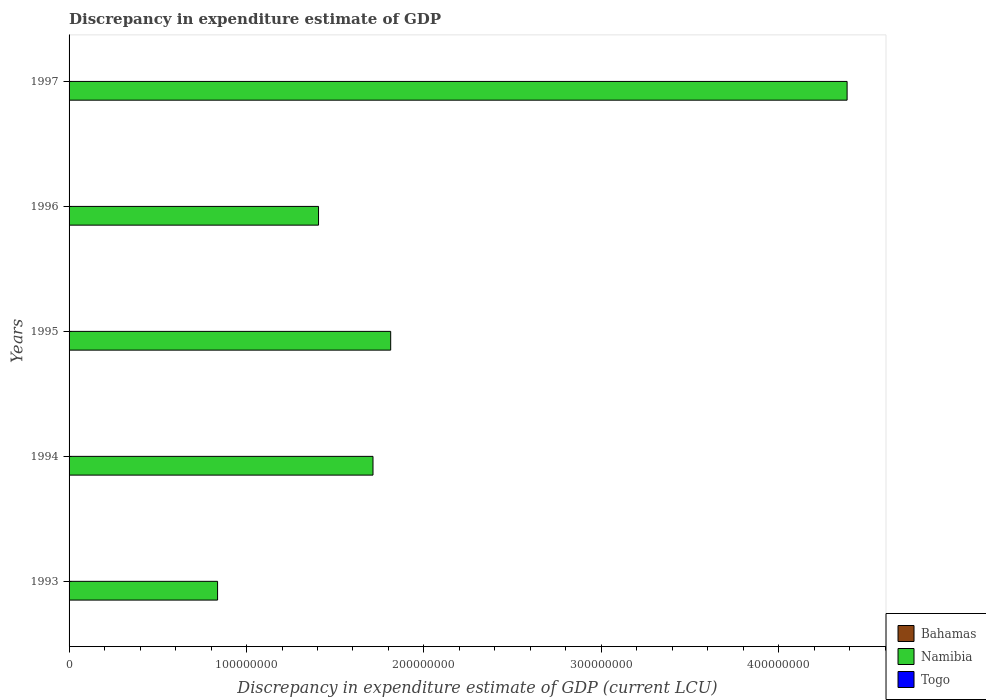How many different coloured bars are there?
Make the answer very short. 2. What is the label of the 3rd group of bars from the top?
Ensure brevity in your answer.  1995. What is the discrepancy in expenditure estimate of GDP in Togo in 1993?
Your answer should be compact. 1.02e+04. Across all years, what is the maximum discrepancy in expenditure estimate of GDP in Namibia?
Your answer should be compact. 4.38e+08. What is the total discrepancy in expenditure estimate of GDP in Togo in the graph?
Keep it short and to the point. 5.12e+04. What is the difference between the discrepancy in expenditure estimate of GDP in Namibia in 1994 and that in 1996?
Provide a short and direct response. 3.07e+07. What is the difference between the discrepancy in expenditure estimate of GDP in Togo in 1993 and the discrepancy in expenditure estimate of GDP in Bahamas in 1997?
Provide a succinct answer. 1.02e+04. In the year 1997, what is the difference between the discrepancy in expenditure estimate of GDP in Namibia and discrepancy in expenditure estimate of GDP in Togo?
Offer a very short reply. 4.38e+08. In how many years, is the discrepancy in expenditure estimate of GDP in Togo greater than 60000000 LCU?
Keep it short and to the point. 0. What is the ratio of the discrepancy in expenditure estimate of GDP in Togo in 1993 to that in 1994?
Make the answer very short. 102. What is the difference between the highest and the second highest discrepancy in expenditure estimate of GDP in Togo?
Keep it short and to the point. 1.44e+04. What is the difference between the highest and the lowest discrepancy in expenditure estimate of GDP in Togo?
Your response must be concise. 2.45e+04. Is the sum of the discrepancy in expenditure estimate of GDP in Togo in 1995 and 1996 greater than the maximum discrepancy in expenditure estimate of GDP in Bahamas across all years?
Provide a succinct answer. Yes. How many bars are there?
Give a very brief answer. 10. Does the graph contain any zero values?
Your answer should be compact. Yes. Where does the legend appear in the graph?
Make the answer very short. Bottom right. How many legend labels are there?
Give a very brief answer. 3. What is the title of the graph?
Your answer should be very brief. Discrepancy in expenditure estimate of GDP. What is the label or title of the X-axis?
Ensure brevity in your answer.  Discrepancy in expenditure estimate of GDP (current LCU). What is the Discrepancy in expenditure estimate of GDP (current LCU) in Namibia in 1993?
Offer a very short reply. 8.37e+07. What is the Discrepancy in expenditure estimate of GDP (current LCU) of Togo in 1993?
Ensure brevity in your answer.  1.02e+04. What is the Discrepancy in expenditure estimate of GDP (current LCU) in Namibia in 1994?
Make the answer very short. 1.71e+08. What is the Discrepancy in expenditure estimate of GDP (current LCU) of Bahamas in 1995?
Your answer should be compact. 0. What is the Discrepancy in expenditure estimate of GDP (current LCU) in Namibia in 1995?
Give a very brief answer. 1.81e+08. What is the Discrepancy in expenditure estimate of GDP (current LCU) in Togo in 1995?
Offer a very short reply. 8100. What is the Discrepancy in expenditure estimate of GDP (current LCU) in Bahamas in 1996?
Offer a terse response. 0. What is the Discrepancy in expenditure estimate of GDP (current LCU) in Namibia in 1996?
Ensure brevity in your answer.  1.41e+08. What is the Discrepancy in expenditure estimate of GDP (current LCU) in Togo in 1996?
Your response must be concise. 2.46e+04. What is the Discrepancy in expenditure estimate of GDP (current LCU) in Namibia in 1997?
Keep it short and to the point. 4.38e+08. What is the Discrepancy in expenditure estimate of GDP (current LCU) in Togo in 1997?
Provide a short and direct response. 8200. Across all years, what is the maximum Discrepancy in expenditure estimate of GDP (current LCU) in Namibia?
Offer a very short reply. 4.38e+08. Across all years, what is the maximum Discrepancy in expenditure estimate of GDP (current LCU) in Togo?
Make the answer very short. 2.46e+04. Across all years, what is the minimum Discrepancy in expenditure estimate of GDP (current LCU) in Namibia?
Give a very brief answer. 8.37e+07. What is the total Discrepancy in expenditure estimate of GDP (current LCU) in Bahamas in the graph?
Provide a succinct answer. 0. What is the total Discrepancy in expenditure estimate of GDP (current LCU) in Namibia in the graph?
Make the answer very short. 1.02e+09. What is the total Discrepancy in expenditure estimate of GDP (current LCU) of Togo in the graph?
Offer a very short reply. 5.12e+04. What is the difference between the Discrepancy in expenditure estimate of GDP (current LCU) of Namibia in 1993 and that in 1994?
Offer a very short reply. -8.76e+07. What is the difference between the Discrepancy in expenditure estimate of GDP (current LCU) in Togo in 1993 and that in 1994?
Make the answer very short. 1.01e+04. What is the difference between the Discrepancy in expenditure estimate of GDP (current LCU) of Namibia in 1993 and that in 1995?
Keep it short and to the point. -9.76e+07. What is the difference between the Discrepancy in expenditure estimate of GDP (current LCU) in Togo in 1993 and that in 1995?
Your response must be concise. 2100. What is the difference between the Discrepancy in expenditure estimate of GDP (current LCU) in Namibia in 1993 and that in 1996?
Give a very brief answer. -5.69e+07. What is the difference between the Discrepancy in expenditure estimate of GDP (current LCU) of Togo in 1993 and that in 1996?
Ensure brevity in your answer.  -1.44e+04. What is the difference between the Discrepancy in expenditure estimate of GDP (current LCU) in Namibia in 1993 and that in 1997?
Make the answer very short. -3.55e+08. What is the difference between the Discrepancy in expenditure estimate of GDP (current LCU) of Togo in 1993 and that in 1997?
Provide a short and direct response. 2000. What is the difference between the Discrepancy in expenditure estimate of GDP (current LCU) of Namibia in 1994 and that in 1995?
Give a very brief answer. -9.97e+06. What is the difference between the Discrepancy in expenditure estimate of GDP (current LCU) in Togo in 1994 and that in 1995?
Provide a short and direct response. -8000. What is the difference between the Discrepancy in expenditure estimate of GDP (current LCU) in Namibia in 1994 and that in 1996?
Your answer should be compact. 3.07e+07. What is the difference between the Discrepancy in expenditure estimate of GDP (current LCU) in Togo in 1994 and that in 1996?
Provide a succinct answer. -2.45e+04. What is the difference between the Discrepancy in expenditure estimate of GDP (current LCU) of Namibia in 1994 and that in 1997?
Your answer should be compact. -2.67e+08. What is the difference between the Discrepancy in expenditure estimate of GDP (current LCU) in Togo in 1994 and that in 1997?
Keep it short and to the point. -8100. What is the difference between the Discrepancy in expenditure estimate of GDP (current LCU) in Namibia in 1995 and that in 1996?
Give a very brief answer. 4.07e+07. What is the difference between the Discrepancy in expenditure estimate of GDP (current LCU) of Togo in 1995 and that in 1996?
Offer a terse response. -1.65e+04. What is the difference between the Discrepancy in expenditure estimate of GDP (current LCU) in Namibia in 1995 and that in 1997?
Offer a very short reply. -2.57e+08. What is the difference between the Discrepancy in expenditure estimate of GDP (current LCU) in Togo in 1995 and that in 1997?
Your answer should be very brief. -100. What is the difference between the Discrepancy in expenditure estimate of GDP (current LCU) of Namibia in 1996 and that in 1997?
Offer a terse response. -2.98e+08. What is the difference between the Discrepancy in expenditure estimate of GDP (current LCU) in Togo in 1996 and that in 1997?
Ensure brevity in your answer.  1.64e+04. What is the difference between the Discrepancy in expenditure estimate of GDP (current LCU) in Namibia in 1993 and the Discrepancy in expenditure estimate of GDP (current LCU) in Togo in 1994?
Offer a terse response. 8.37e+07. What is the difference between the Discrepancy in expenditure estimate of GDP (current LCU) in Namibia in 1993 and the Discrepancy in expenditure estimate of GDP (current LCU) in Togo in 1995?
Make the answer very short. 8.37e+07. What is the difference between the Discrepancy in expenditure estimate of GDP (current LCU) in Namibia in 1993 and the Discrepancy in expenditure estimate of GDP (current LCU) in Togo in 1996?
Keep it short and to the point. 8.37e+07. What is the difference between the Discrepancy in expenditure estimate of GDP (current LCU) of Namibia in 1993 and the Discrepancy in expenditure estimate of GDP (current LCU) of Togo in 1997?
Keep it short and to the point. 8.37e+07. What is the difference between the Discrepancy in expenditure estimate of GDP (current LCU) of Namibia in 1994 and the Discrepancy in expenditure estimate of GDP (current LCU) of Togo in 1995?
Offer a very short reply. 1.71e+08. What is the difference between the Discrepancy in expenditure estimate of GDP (current LCU) of Namibia in 1994 and the Discrepancy in expenditure estimate of GDP (current LCU) of Togo in 1996?
Keep it short and to the point. 1.71e+08. What is the difference between the Discrepancy in expenditure estimate of GDP (current LCU) of Namibia in 1994 and the Discrepancy in expenditure estimate of GDP (current LCU) of Togo in 1997?
Your response must be concise. 1.71e+08. What is the difference between the Discrepancy in expenditure estimate of GDP (current LCU) in Namibia in 1995 and the Discrepancy in expenditure estimate of GDP (current LCU) in Togo in 1996?
Offer a terse response. 1.81e+08. What is the difference between the Discrepancy in expenditure estimate of GDP (current LCU) in Namibia in 1995 and the Discrepancy in expenditure estimate of GDP (current LCU) in Togo in 1997?
Offer a very short reply. 1.81e+08. What is the difference between the Discrepancy in expenditure estimate of GDP (current LCU) in Namibia in 1996 and the Discrepancy in expenditure estimate of GDP (current LCU) in Togo in 1997?
Your response must be concise. 1.41e+08. What is the average Discrepancy in expenditure estimate of GDP (current LCU) in Namibia per year?
Give a very brief answer. 2.03e+08. What is the average Discrepancy in expenditure estimate of GDP (current LCU) of Togo per year?
Ensure brevity in your answer.  1.02e+04. In the year 1993, what is the difference between the Discrepancy in expenditure estimate of GDP (current LCU) in Namibia and Discrepancy in expenditure estimate of GDP (current LCU) in Togo?
Your answer should be very brief. 8.37e+07. In the year 1994, what is the difference between the Discrepancy in expenditure estimate of GDP (current LCU) in Namibia and Discrepancy in expenditure estimate of GDP (current LCU) in Togo?
Offer a terse response. 1.71e+08. In the year 1995, what is the difference between the Discrepancy in expenditure estimate of GDP (current LCU) of Namibia and Discrepancy in expenditure estimate of GDP (current LCU) of Togo?
Ensure brevity in your answer.  1.81e+08. In the year 1996, what is the difference between the Discrepancy in expenditure estimate of GDP (current LCU) of Namibia and Discrepancy in expenditure estimate of GDP (current LCU) of Togo?
Your response must be concise. 1.41e+08. In the year 1997, what is the difference between the Discrepancy in expenditure estimate of GDP (current LCU) in Namibia and Discrepancy in expenditure estimate of GDP (current LCU) in Togo?
Your response must be concise. 4.38e+08. What is the ratio of the Discrepancy in expenditure estimate of GDP (current LCU) of Namibia in 1993 to that in 1994?
Provide a succinct answer. 0.49. What is the ratio of the Discrepancy in expenditure estimate of GDP (current LCU) in Togo in 1993 to that in 1994?
Ensure brevity in your answer.  102. What is the ratio of the Discrepancy in expenditure estimate of GDP (current LCU) of Namibia in 1993 to that in 1995?
Keep it short and to the point. 0.46. What is the ratio of the Discrepancy in expenditure estimate of GDP (current LCU) in Togo in 1993 to that in 1995?
Ensure brevity in your answer.  1.26. What is the ratio of the Discrepancy in expenditure estimate of GDP (current LCU) in Namibia in 1993 to that in 1996?
Make the answer very short. 0.6. What is the ratio of the Discrepancy in expenditure estimate of GDP (current LCU) of Togo in 1993 to that in 1996?
Offer a terse response. 0.41. What is the ratio of the Discrepancy in expenditure estimate of GDP (current LCU) of Namibia in 1993 to that in 1997?
Keep it short and to the point. 0.19. What is the ratio of the Discrepancy in expenditure estimate of GDP (current LCU) in Togo in 1993 to that in 1997?
Make the answer very short. 1.24. What is the ratio of the Discrepancy in expenditure estimate of GDP (current LCU) in Namibia in 1994 to that in 1995?
Your answer should be very brief. 0.94. What is the ratio of the Discrepancy in expenditure estimate of GDP (current LCU) in Togo in 1994 to that in 1995?
Your response must be concise. 0.01. What is the ratio of the Discrepancy in expenditure estimate of GDP (current LCU) in Namibia in 1994 to that in 1996?
Make the answer very short. 1.22. What is the ratio of the Discrepancy in expenditure estimate of GDP (current LCU) in Togo in 1994 to that in 1996?
Make the answer very short. 0. What is the ratio of the Discrepancy in expenditure estimate of GDP (current LCU) of Namibia in 1994 to that in 1997?
Make the answer very short. 0.39. What is the ratio of the Discrepancy in expenditure estimate of GDP (current LCU) in Togo in 1994 to that in 1997?
Ensure brevity in your answer.  0.01. What is the ratio of the Discrepancy in expenditure estimate of GDP (current LCU) of Namibia in 1995 to that in 1996?
Make the answer very short. 1.29. What is the ratio of the Discrepancy in expenditure estimate of GDP (current LCU) in Togo in 1995 to that in 1996?
Provide a short and direct response. 0.33. What is the ratio of the Discrepancy in expenditure estimate of GDP (current LCU) in Namibia in 1995 to that in 1997?
Keep it short and to the point. 0.41. What is the ratio of the Discrepancy in expenditure estimate of GDP (current LCU) in Namibia in 1996 to that in 1997?
Your answer should be very brief. 0.32. What is the difference between the highest and the second highest Discrepancy in expenditure estimate of GDP (current LCU) of Namibia?
Your answer should be compact. 2.57e+08. What is the difference between the highest and the second highest Discrepancy in expenditure estimate of GDP (current LCU) in Togo?
Offer a terse response. 1.44e+04. What is the difference between the highest and the lowest Discrepancy in expenditure estimate of GDP (current LCU) of Namibia?
Ensure brevity in your answer.  3.55e+08. What is the difference between the highest and the lowest Discrepancy in expenditure estimate of GDP (current LCU) in Togo?
Offer a very short reply. 2.45e+04. 